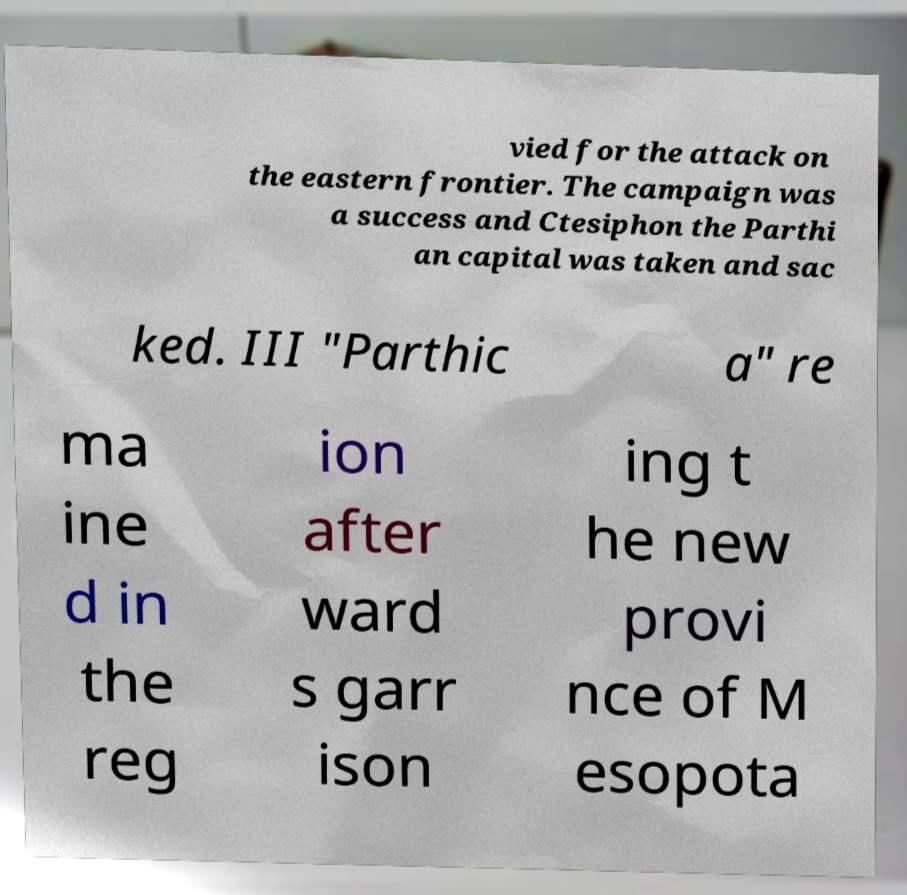Can you read and provide the text displayed in the image?This photo seems to have some interesting text. Can you extract and type it out for me? vied for the attack on the eastern frontier. The campaign was a success and Ctesiphon the Parthi an capital was taken and sac ked. III "Parthic a" re ma ine d in the reg ion after ward s garr ison ing t he new provi nce of M esopota 